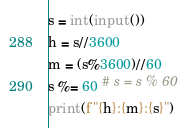Convert code to text. <code><loc_0><loc_0><loc_500><loc_500><_Python_>s = int(input())
h = s//3600
m = (s%3600)//60
s %= 60 # s = s % 60
print(f"{h}:{m}:{s}")
</code> 